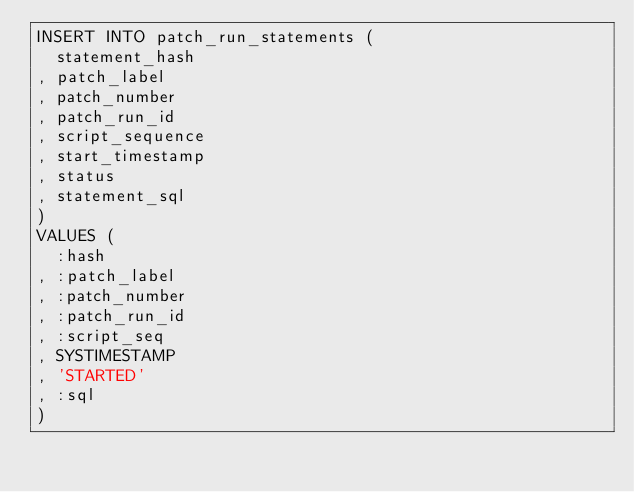<code> <loc_0><loc_0><loc_500><loc_500><_SQL_>INSERT INTO patch_run_statements (
  statement_hash
, patch_label
, patch_number
, patch_run_id
, script_sequence
, start_timestamp
, status
, statement_sql
)
VALUES (
  :hash
, :patch_label
, :patch_number
, :patch_run_id
, :script_seq
, SYSTIMESTAMP
, 'STARTED'
, :sql
)</code> 